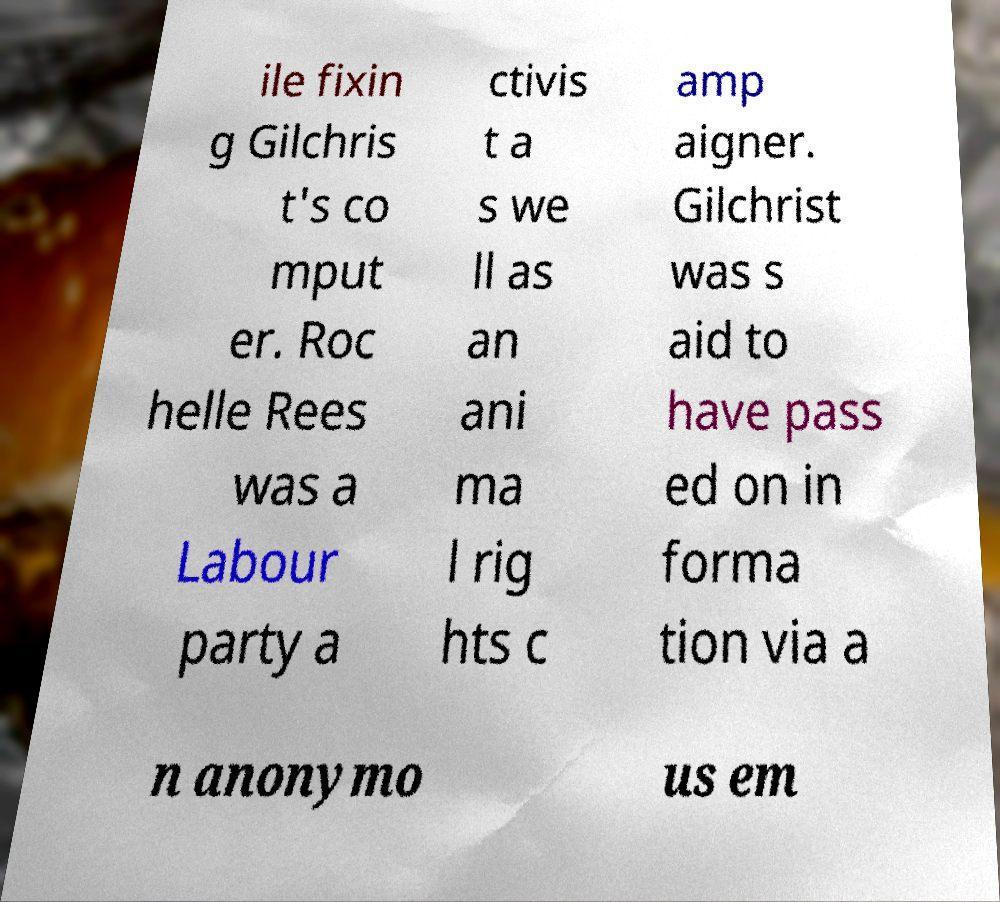Can you read and provide the text displayed in the image?This photo seems to have some interesting text. Can you extract and type it out for me? ile fixin g Gilchris t's co mput er. Roc helle Rees was a Labour party a ctivis t a s we ll as an ani ma l rig hts c amp aigner. Gilchrist was s aid to have pass ed on in forma tion via a n anonymo us em 